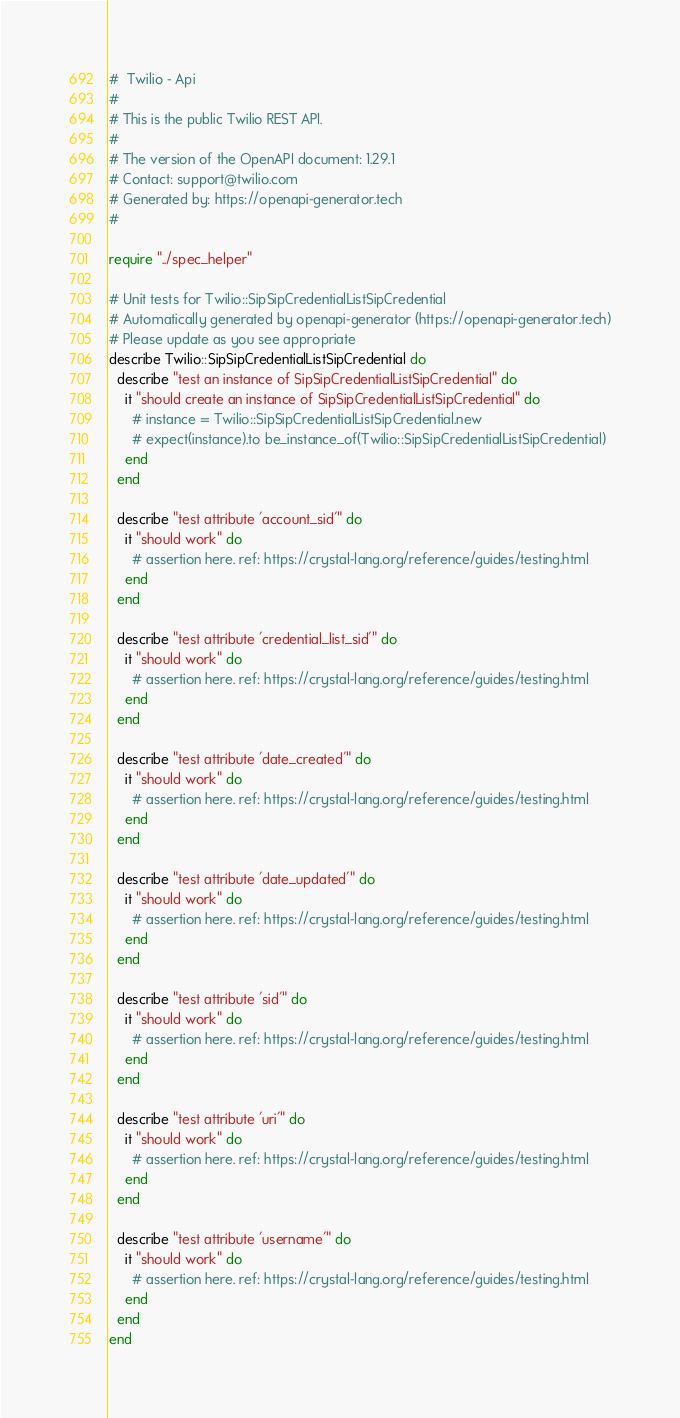Convert code to text. <code><loc_0><loc_0><loc_500><loc_500><_Crystal_>#  Twilio - Api
#
# This is the public Twilio REST API.
#
# The version of the OpenAPI document: 1.29.1
# Contact: support@twilio.com
# Generated by: https://openapi-generator.tech
#

require "../spec_helper"

# Unit tests for Twilio::SipSipCredentialListSipCredential
# Automatically generated by openapi-generator (https://openapi-generator.tech)
# Please update as you see appropriate
describe Twilio::SipSipCredentialListSipCredential do
  describe "test an instance of SipSipCredentialListSipCredential" do
    it "should create an instance of SipSipCredentialListSipCredential" do
      # instance = Twilio::SipSipCredentialListSipCredential.new
      # expect(instance).to be_instance_of(Twilio::SipSipCredentialListSipCredential)
    end
  end

  describe "test attribute 'account_sid'" do
    it "should work" do
      # assertion here. ref: https://crystal-lang.org/reference/guides/testing.html
    end
  end

  describe "test attribute 'credential_list_sid'" do
    it "should work" do
      # assertion here. ref: https://crystal-lang.org/reference/guides/testing.html
    end
  end

  describe "test attribute 'date_created'" do
    it "should work" do
      # assertion here. ref: https://crystal-lang.org/reference/guides/testing.html
    end
  end

  describe "test attribute 'date_updated'" do
    it "should work" do
      # assertion here. ref: https://crystal-lang.org/reference/guides/testing.html
    end
  end

  describe "test attribute 'sid'" do
    it "should work" do
      # assertion here. ref: https://crystal-lang.org/reference/guides/testing.html
    end
  end

  describe "test attribute 'uri'" do
    it "should work" do
      # assertion here. ref: https://crystal-lang.org/reference/guides/testing.html
    end
  end

  describe "test attribute 'username'" do
    it "should work" do
      # assertion here. ref: https://crystal-lang.org/reference/guides/testing.html
    end
  end
end
</code> 